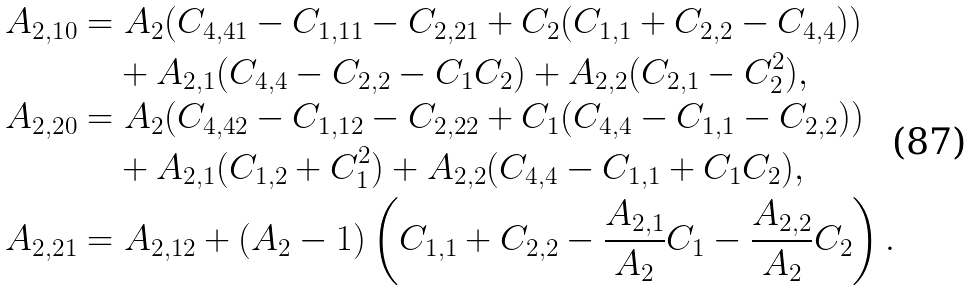Convert formula to latex. <formula><loc_0><loc_0><loc_500><loc_500>A _ { 2 , 1 0 } & = A _ { 2 } ( C _ { 4 , 4 1 } - C _ { 1 , 1 1 } - C _ { 2 , 2 1 } + C _ { 2 } ( C _ { 1 , 1 } + C _ { 2 , 2 } - C _ { 4 , 4 } ) ) \\ & \quad + A _ { 2 , 1 } ( C _ { 4 , 4 } - C _ { 2 , 2 } - C _ { 1 } C _ { 2 } ) + A _ { 2 , 2 } ( C _ { 2 , 1 } - C _ { 2 } ^ { 2 } ) , \\ A _ { 2 , 2 0 } & = A _ { 2 } ( C _ { 4 , 4 2 } - C _ { 1 , 1 2 } - C _ { 2 , 2 2 } + C _ { 1 } ( C _ { 4 , 4 } - C _ { 1 , 1 } - C _ { 2 , 2 } ) ) \\ & \quad + A _ { 2 , 1 } ( C _ { 1 , 2 } + C _ { 1 } ^ { 2 } ) + A _ { 2 , 2 } ( C _ { 4 , 4 } - C _ { 1 , 1 } + C _ { 1 } C _ { 2 } ) , \\ A _ { 2 , 2 1 } & = A _ { 2 , 1 2 } + ( A _ { 2 } - 1 ) \left ( C _ { 1 , 1 } + C _ { 2 , 2 } - \frac { A _ { 2 , 1 } } { A _ { 2 } } C _ { 1 } - \frac { A _ { 2 , 2 } } { A _ { 2 } } C _ { 2 } \right ) .</formula> 